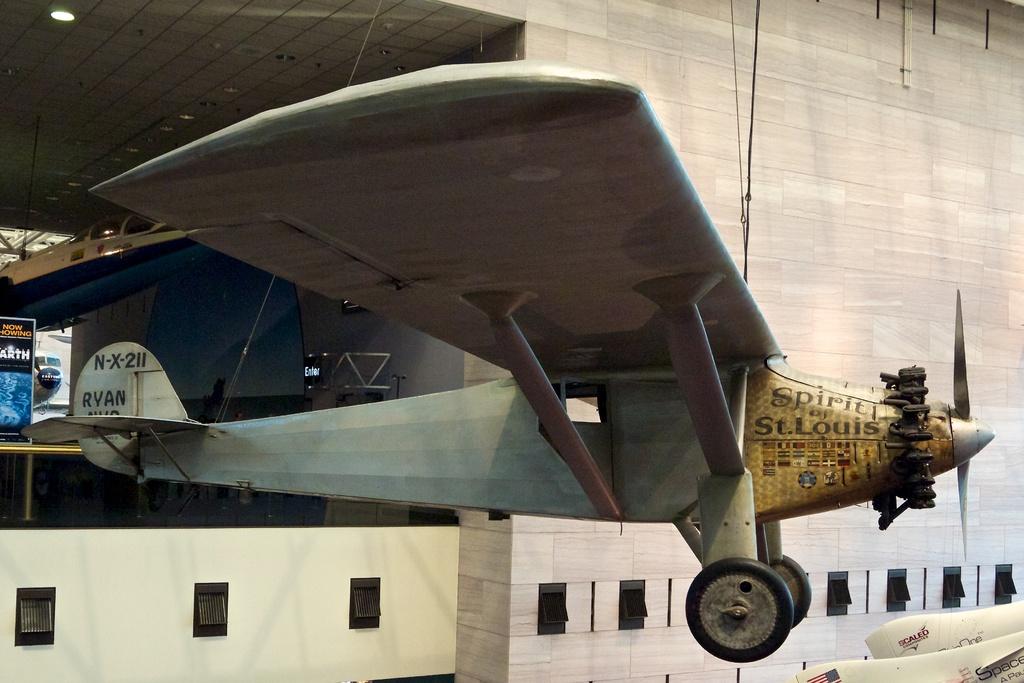Spirt of what is written on the plane?
Your answer should be very brief. St. louis. What is the plane number?
Provide a succinct answer. N-x-211. 